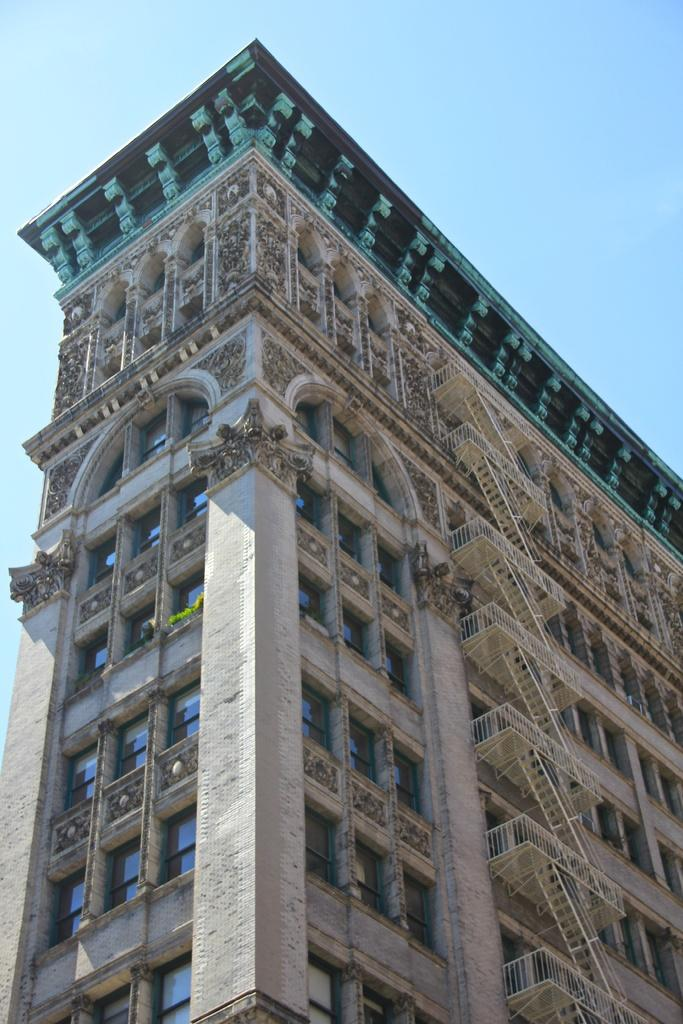What is the main subject of the picture? The main subject of the picture is a building. What specific features can be seen on the building? The building has windows and staircases. What can be seen in the background of the picture? The sky is visible in the background of the picture. What type of fuel is being used by the country depicted in the image? There is no country or fuel mentioned in the image; it only features a building with windows and staircases, and a visible sky in the background. 